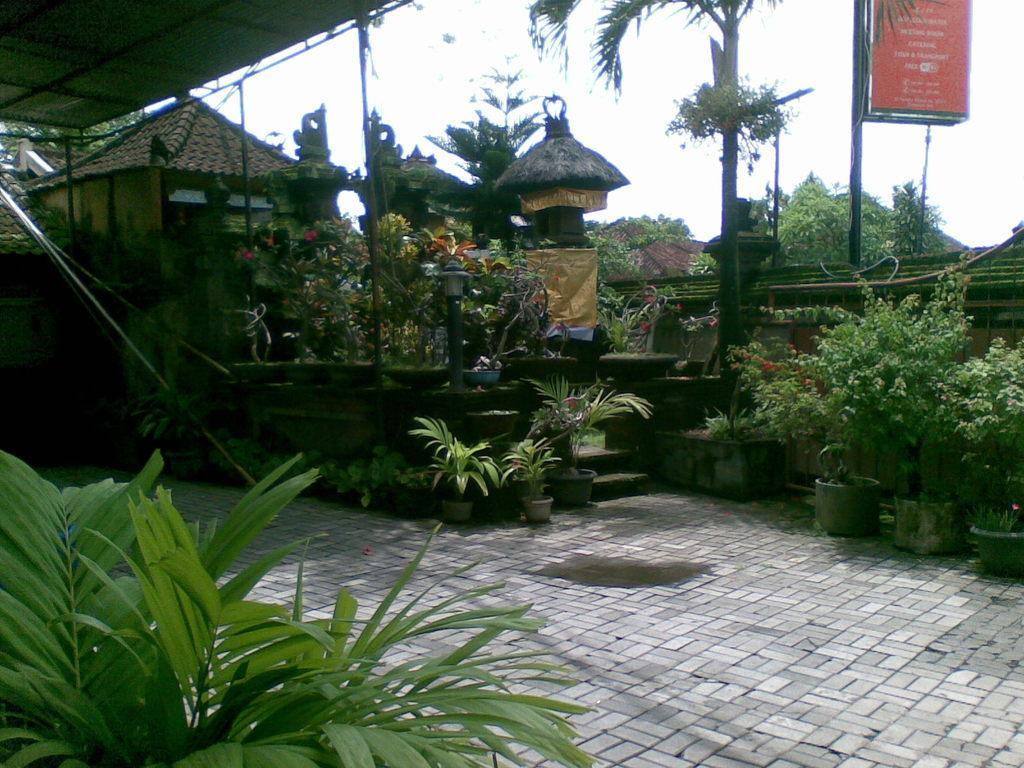Can you describe this image briefly? In this image we can see group of plants placed in different pots on the ground. In the background, we can see a group of buildings, trees, shed and the sky. 